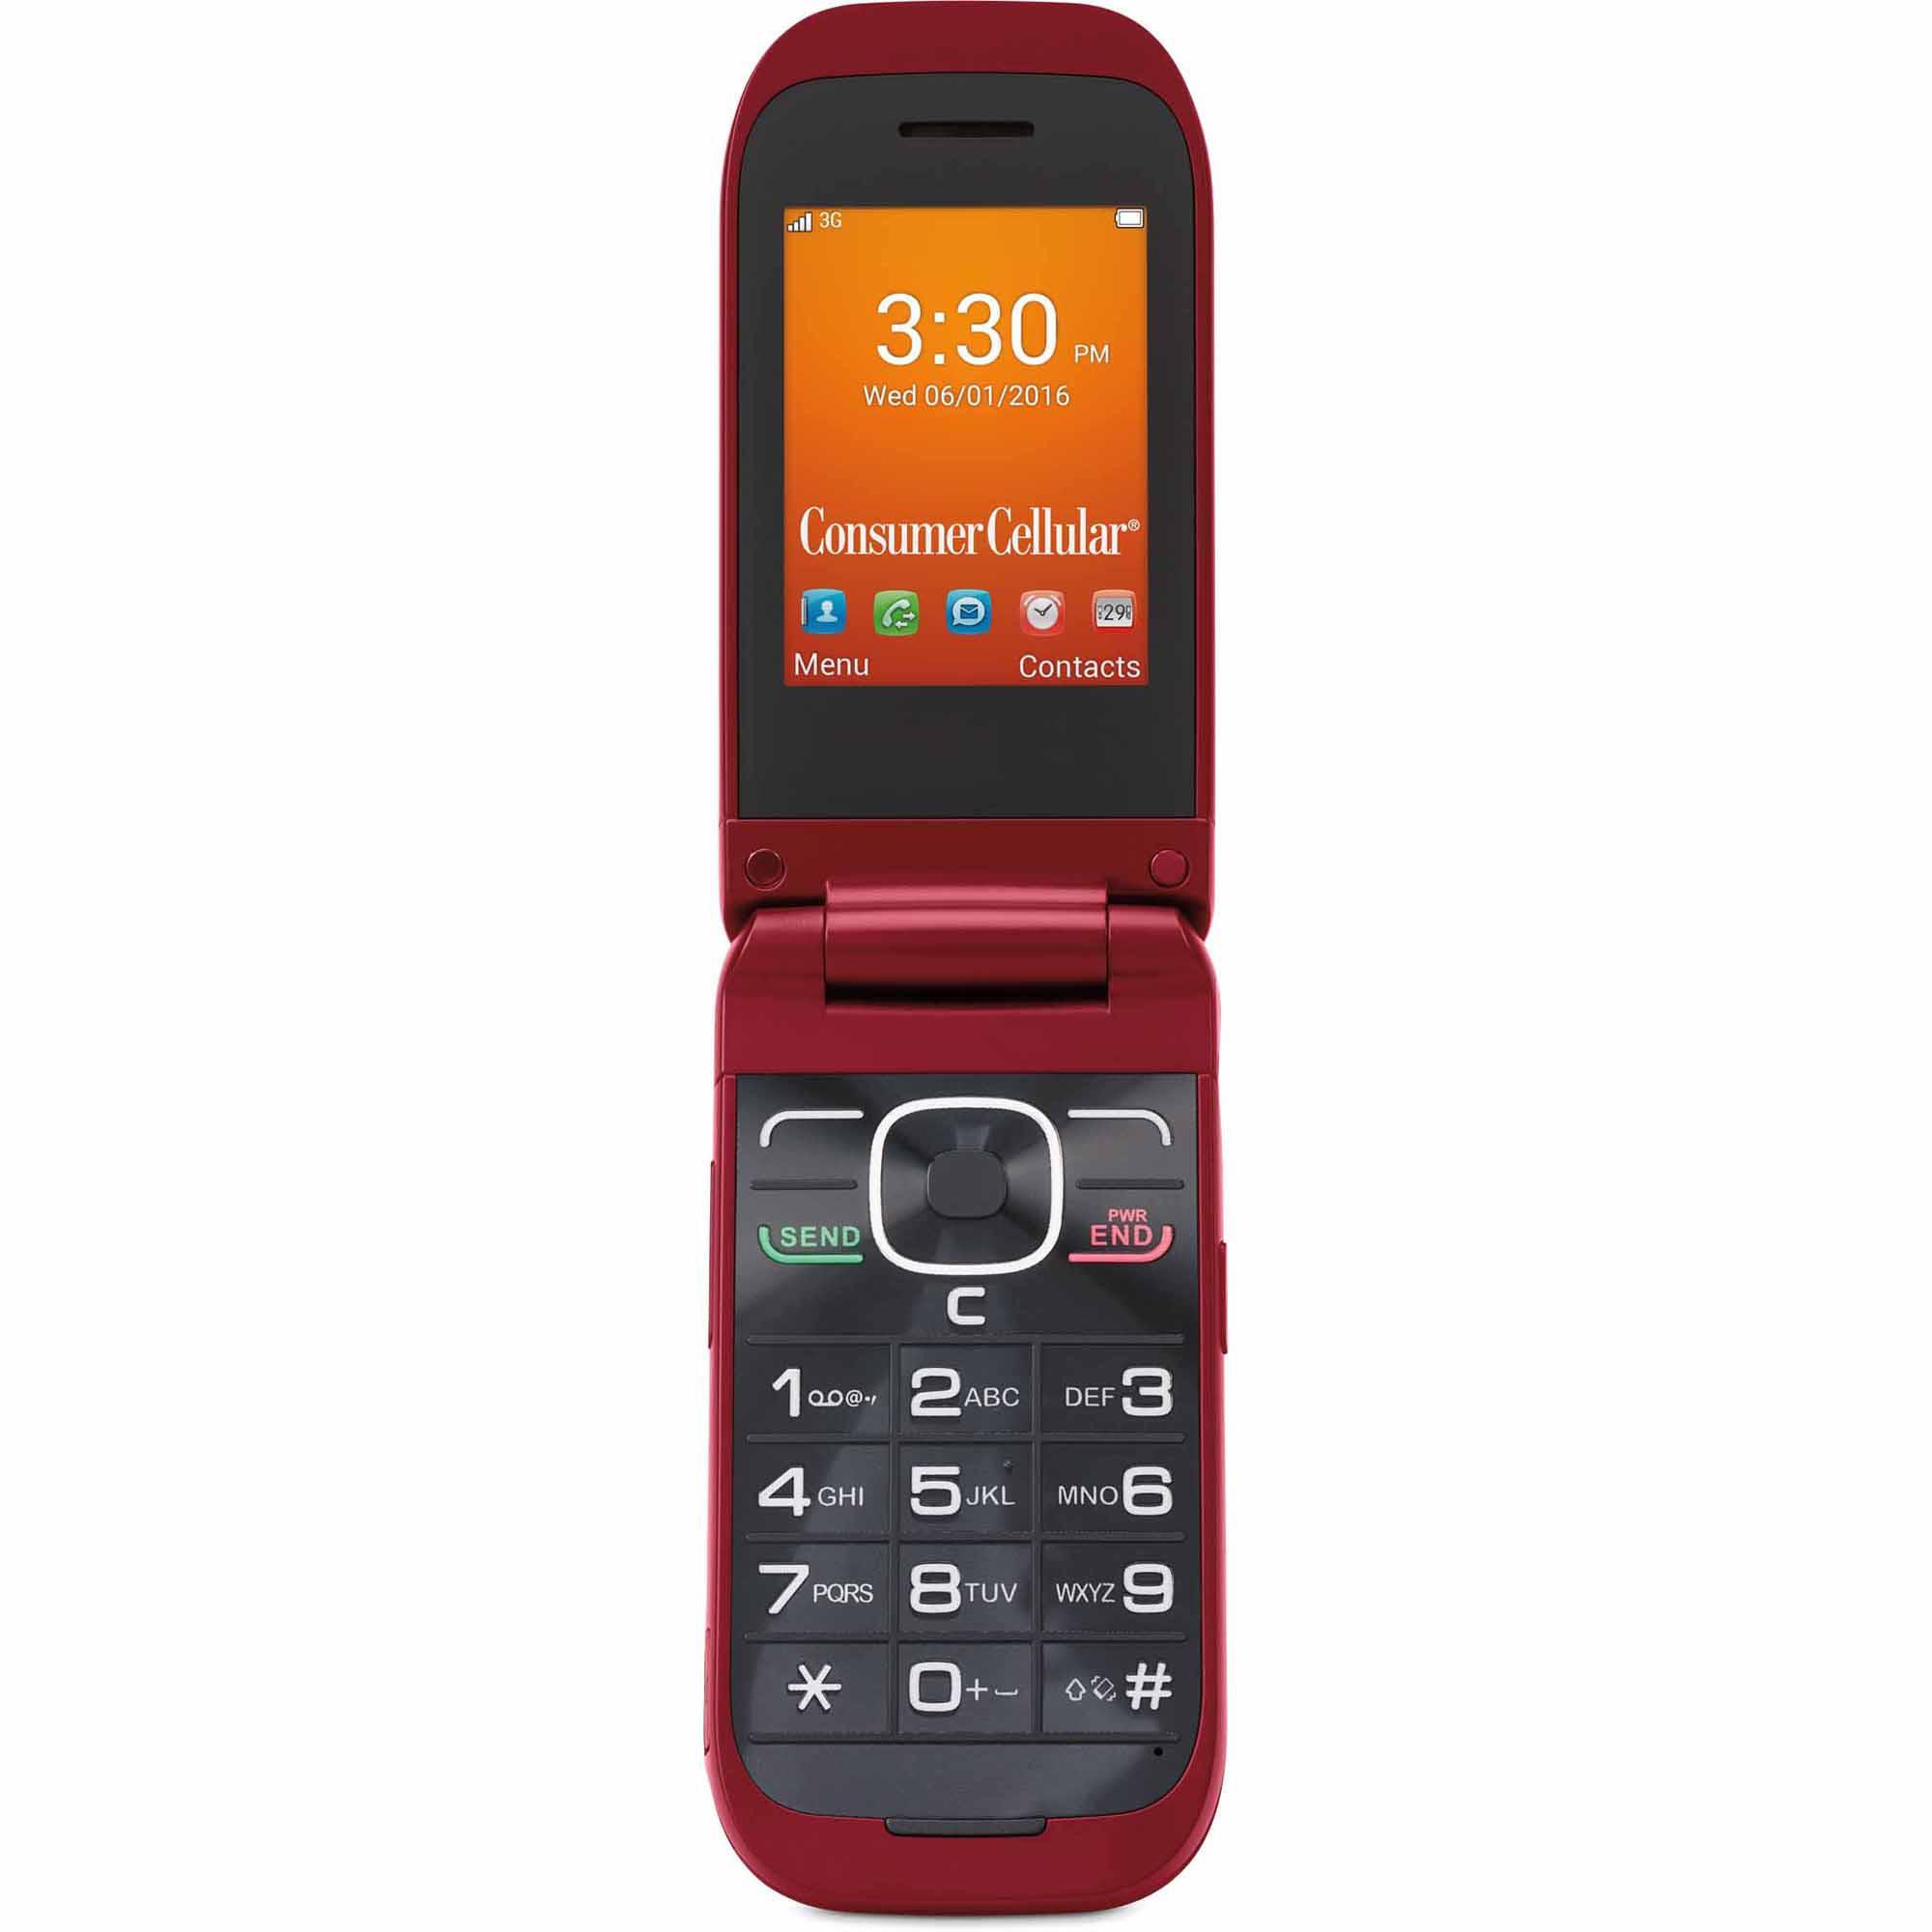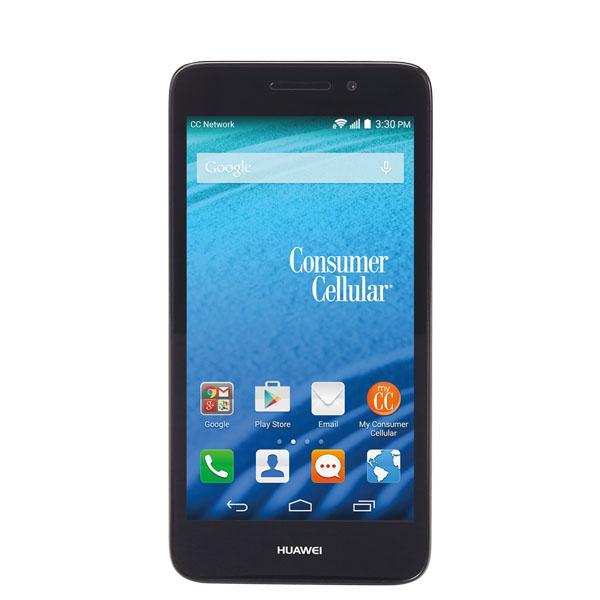The first image is the image on the left, the second image is the image on the right. Analyze the images presented: Is the assertion "One phone is white around the screen." valid? Answer yes or no. No. The first image is the image on the left, the second image is the image on the right. Analyze the images presented: Is the assertion "One image shows a flat phone with a big screen displayed head-on and vertically, and the other image includes a phone with an antenna that is displayed at an angle." valid? Answer yes or no. No. 